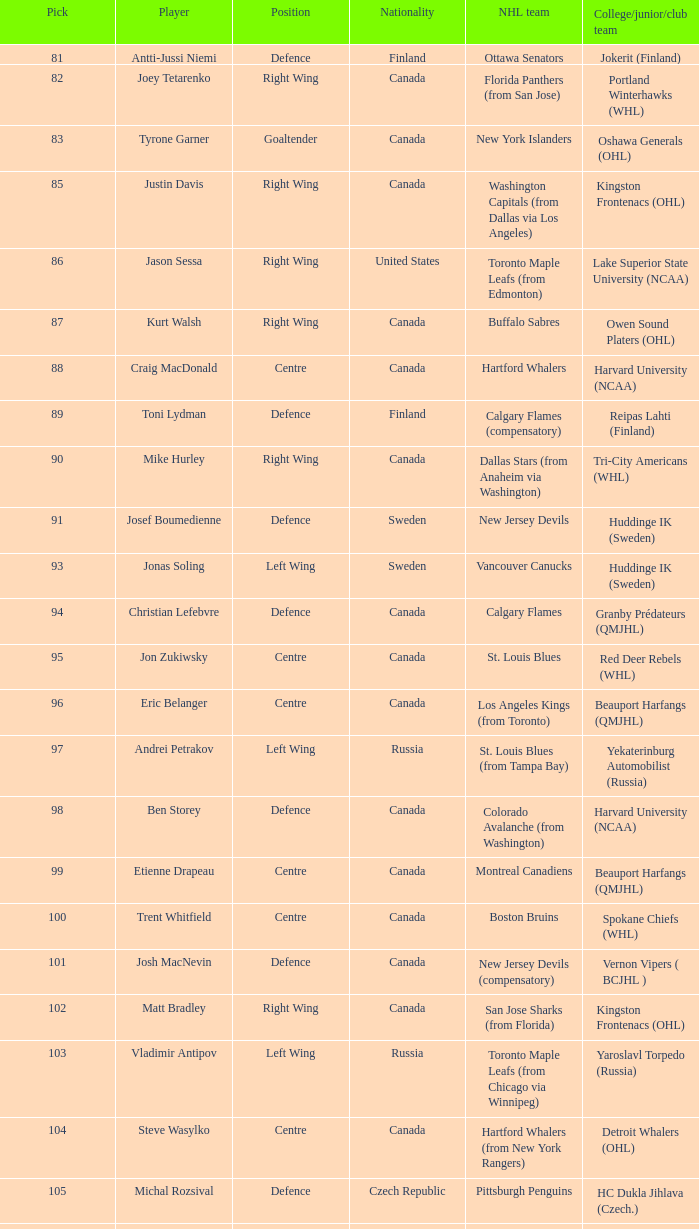Can you give me this table as a dict? {'header': ['Pick', 'Player', 'Position', 'Nationality', 'NHL team', 'College/junior/club team'], 'rows': [['81', 'Antti-Jussi Niemi', 'Defence', 'Finland', 'Ottawa Senators', 'Jokerit (Finland)'], ['82', 'Joey Tetarenko', 'Right Wing', 'Canada', 'Florida Panthers (from San Jose)', 'Portland Winterhawks (WHL)'], ['83', 'Tyrone Garner', 'Goaltender', 'Canada', 'New York Islanders', 'Oshawa Generals (OHL)'], ['85', 'Justin Davis', 'Right Wing', 'Canada', 'Washington Capitals (from Dallas via Los Angeles)', 'Kingston Frontenacs (OHL)'], ['86', 'Jason Sessa', 'Right Wing', 'United States', 'Toronto Maple Leafs (from Edmonton)', 'Lake Superior State University (NCAA)'], ['87', 'Kurt Walsh', 'Right Wing', 'Canada', 'Buffalo Sabres', 'Owen Sound Platers (OHL)'], ['88', 'Craig MacDonald', 'Centre', 'Canada', 'Hartford Whalers', 'Harvard University (NCAA)'], ['89', 'Toni Lydman', 'Defence', 'Finland', 'Calgary Flames (compensatory)', 'Reipas Lahti (Finland)'], ['90', 'Mike Hurley', 'Right Wing', 'Canada', 'Dallas Stars (from Anaheim via Washington)', 'Tri-City Americans (WHL)'], ['91', 'Josef Boumedienne', 'Defence', 'Sweden', 'New Jersey Devils', 'Huddinge IK (Sweden)'], ['93', 'Jonas Soling', 'Left Wing', 'Sweden', 'Vancouver Canucks', 'Huddinge IK (Sweden)'], ['94', 'Christian Lefebvre', 'Defence', 'Canada', 'Calgary Flames', 'Granby Prédateurs (QMJHL)'], ['95', 'Jon Zukiwsky', 'Centre', 'Canada', 'St. Louis Blues', 'Red Deer Rebels (WHL)'], ['96', 'Eric Belanger', 'Centre', 'Canada', 'Los Angeles Kings (from Toronto)', 'Beauport Harfangs (QMJHL)'], ['97', 'Andrei Petrakov', 'Left Wing', 'Russia', 'St. Louis Blues (from Tampa Bay)', 'Yekaterinburg Automobilist (Russia)'], ['98', 'Ben Storey', 'Defence', 'Canada', 'Colorado Avalanche (from Washington)', 'Harvard University (NCAA)'], ['99', 'Etienne Drapeau', 'Centre', 'Canada', 'Montreal Canadiens', 'Beauport Harfangs (QMJHL)'], ['100', 'Trent Whitfield', 'Centre', 'Canada', 'Boston Bruins', 'Spokane Chiefs (WHL)'], ['101', 'Josh MacNevin', 'Defence', 'Canada', 'New Jersey Devils (compensatory)', 'Vernon Vipers ( BCJHL )'], ['102', 'Matt Bradley', 'Right Wing', 'Canada', 'San Jose Sharks (from Florida)', 'Kingston Frontenacs (OHL)'], ['103', 'Vladimir Antipov', 'Left Wing', 'Russia', 'Toronto Maple Leafs (from Chicago via Winnipeg)', 'Yaroslavl Torpedo (Russia)'], ['104', 'Steve Wasylko', 'Centre', 'Canada', 'Hartford Whalers (from New York Rangers)', 'Detroit Whalers (OHL)'], ['105', 'Michal Rozsival', 'Defence', 'Czech Republic', 'Pittsburgh Penguins', 'HC Dukla Jihlava (Czech.)'], ['106', 'Mike Martone', 'Defence', 'Canada', 'Buffalo Sabres (from Philadelphia via San Jose)', 'Peterborough Petes (OHL)'], ['107', 'Randy Petruk', 'Goaltender', 'Canada', 'Colorado Avalanche', 'Kamloops Blazers (WHL)']]} How many positions in the draft pick did matt bradley hold? 1.0. 